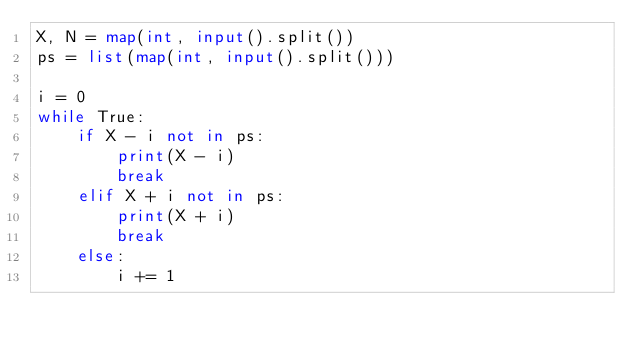Convert code to text. <code><loc_0><loc_0><loc_500><loc_500><_Python_>X, N = map(int, input().split())
ps = list(map(int, input().split()))

i = 0
while True:
    if X - i not in ps:
        print(X - i)
        break
    elif X + i not in ps:
        print(X + i)
        break
    else:
        i += 1
        </code> 